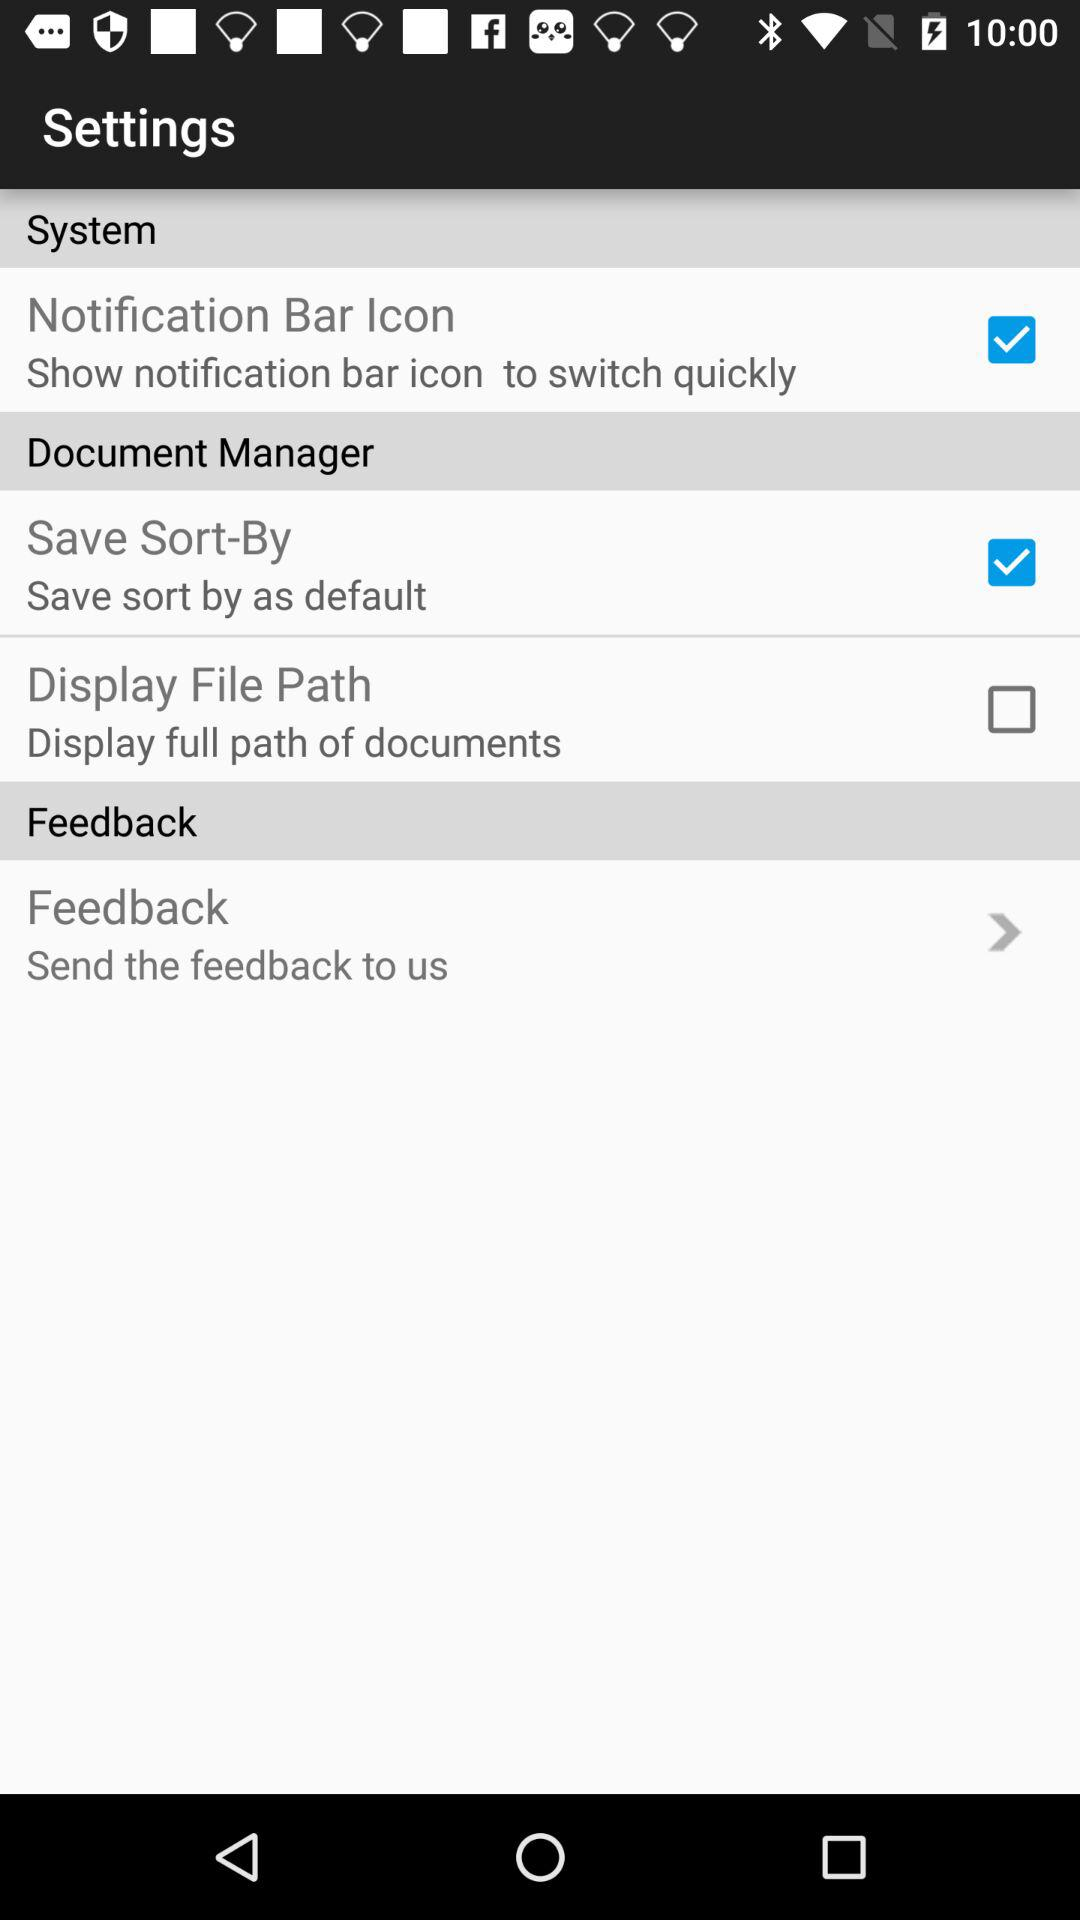What is the status of the "Display File Path"? The status is "off". 